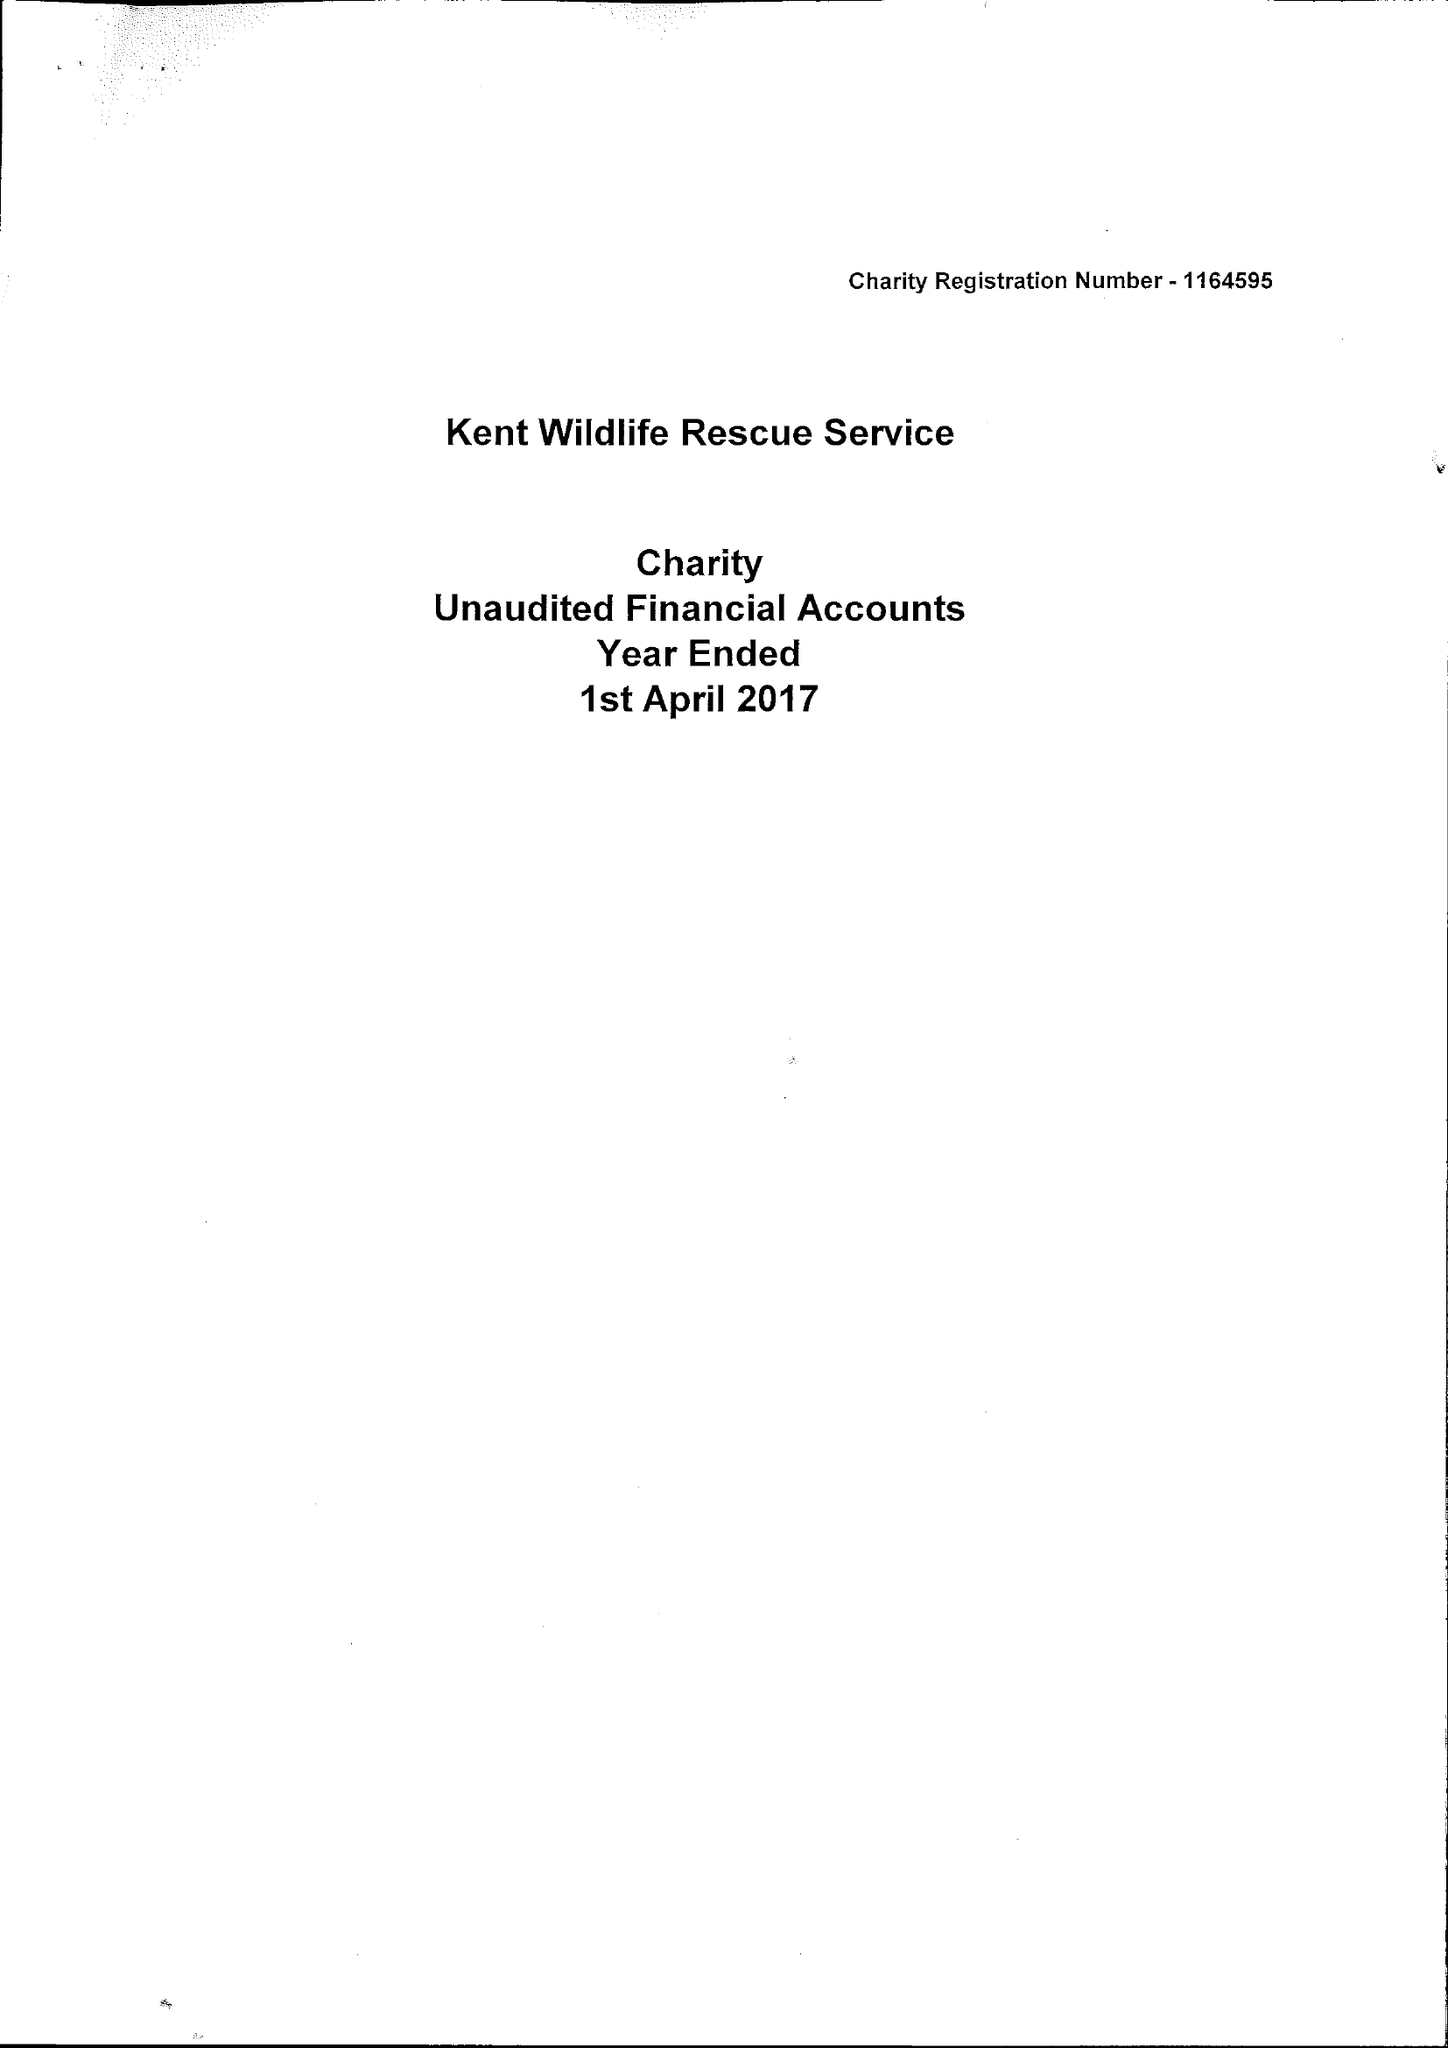What is the value for the address__postcode?
Answer the question using a single word or phrase. ME12 1YF 